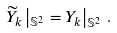<formula> <loc_0><loc_0><loc_500><loc_500>\widetilde { Y } _ { k } \left | _ { \mathbb { S } ^ { 2 } } = Y _ { k } \right | _ { \mathbb { S } ^ { 2 } } \, .</formula> 